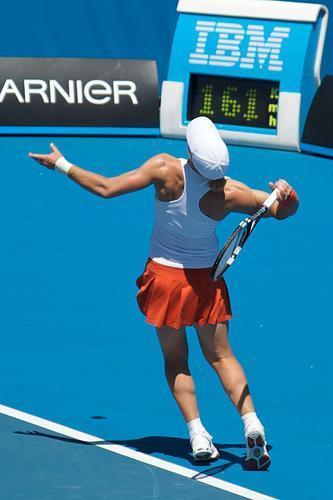How many people are there?
Give a very brief answer. 1. 